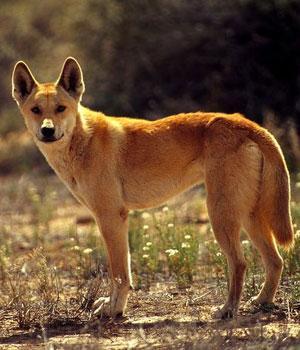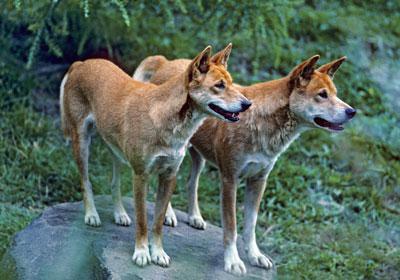The first image is the image on the left, the second image is the image on the right. For the images displayed, is the sentence "The dog on the right image is running." factually correct? Answer yes or no. No. 